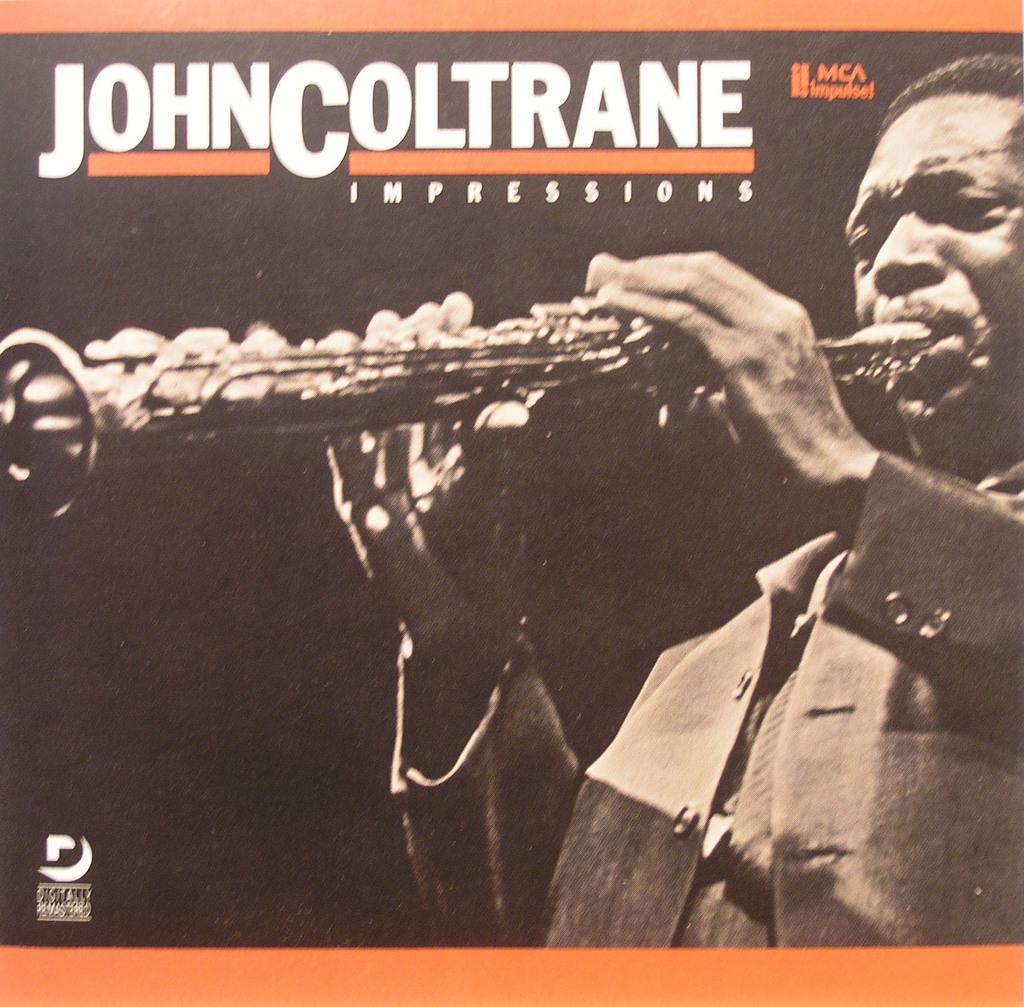Describe this image in one or two sentences. In this picture we can see a cover page, in the cover page we can find a man, he is playing musical instrument. 